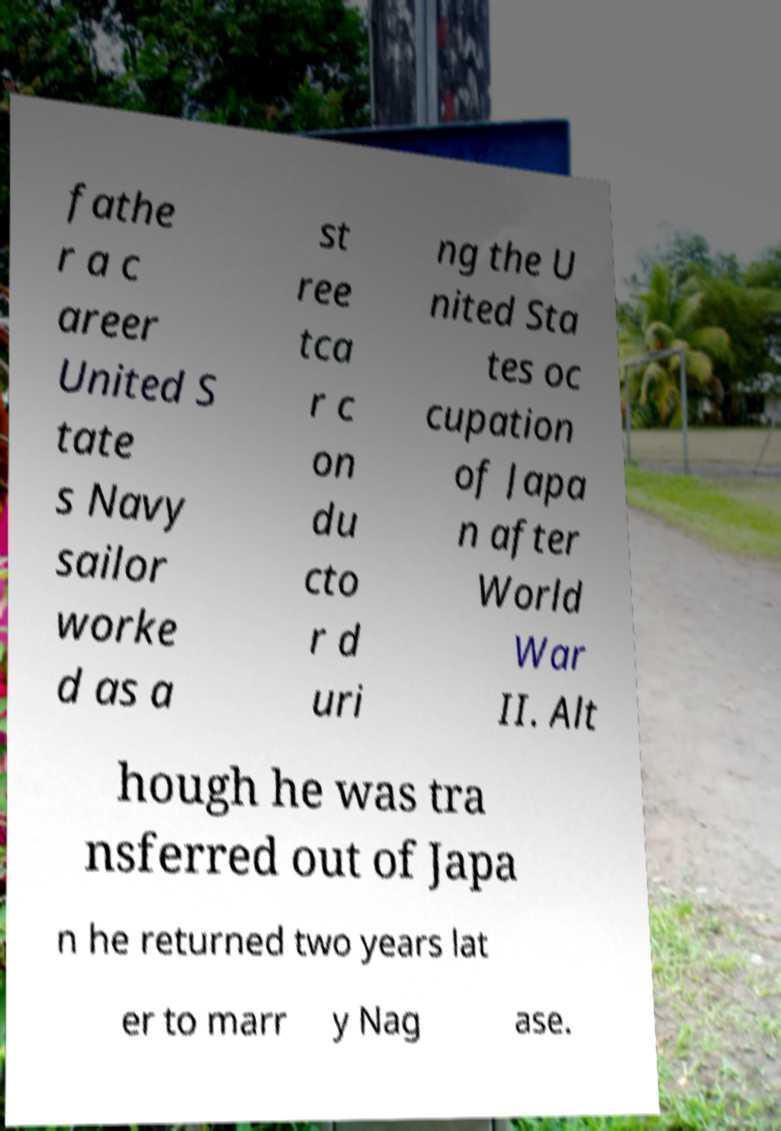There's text embedded in this image that I need extracted. Can you transcribe it verbatim? fathe r a c areer United S tate s Navy sailor worke d as a st ree tca r c on du cto r d uri ng the U nited Sta tes oc cupation of Japa n after World War II. Alt hough he was tra nsferred out of Japa n he returned two years lat er to marr y Nag ase. 